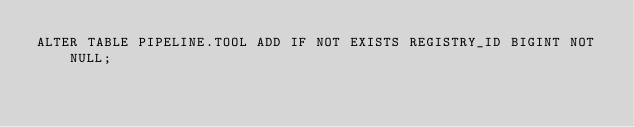Convert code to text. <code><loc_0><loc_0><loc_500><loc_500><_SQL_>ALTER TABLE PIPELINE.TOOL ADD IF NOT EXISTS REGISTRY_ID BIGINT NOT NULL;
</code> 